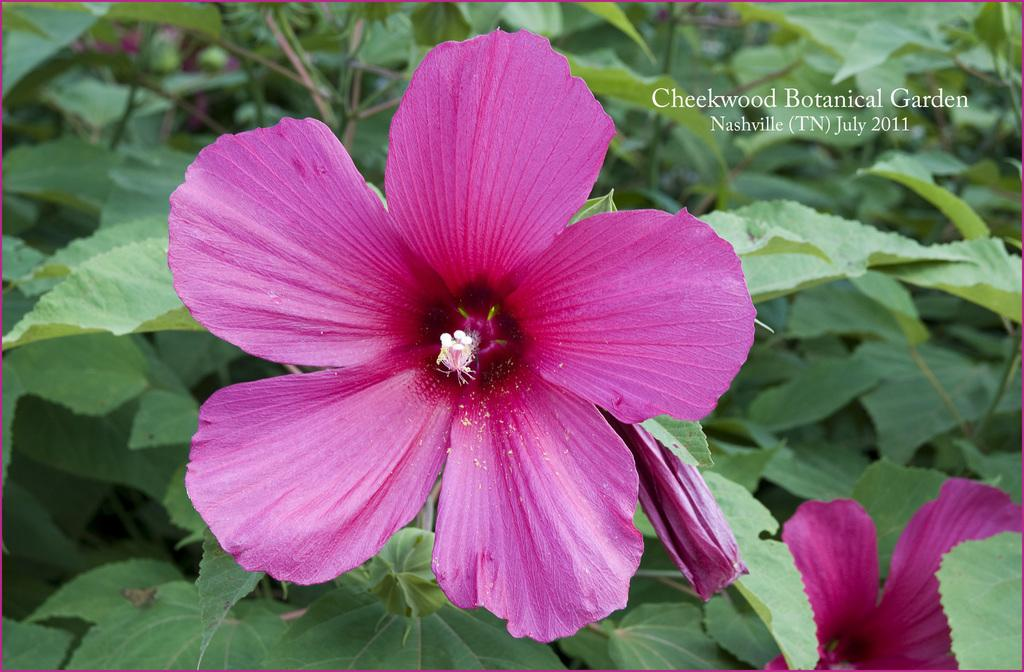What type of flowers are in the image? There are Chinese hibiscus flowers in the image. What color are the flowers? The flowers are pink in color. What else can be seen in the image besides the flowers? There are leaves visible in the image. Is there any additional information about the image? Yes, there is a watermark on the image. How many spots can be seen on the quarter in the image? There is no quarter present in the image, so it is not possible to determine the number of spots. 